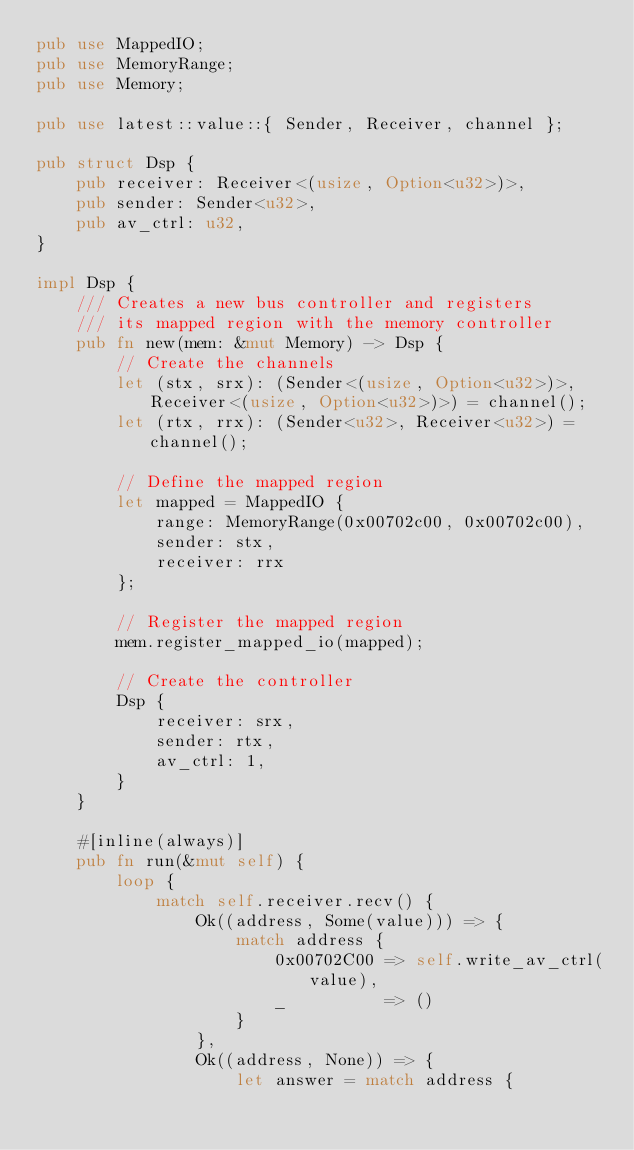Convert code to text. <code><loc_0><loc_0><loc_500><loc_500><_Rust_>pub use MappedIO;
pub use MemoryRange;
pub use Memory;

pub use latest::value::{ Sender, Receiver, channel };

pub struct Dsp {
    pub receiver: Receiver<(usize, Option<u32>)>,
    pub sender: Sender<u32>,
    pub av_ctrl: u32,
}

impl Dsp {
    /// Creates a new bus controller and registers
    /// its mapped region with the memory controller
    pub fn new(mem: &mut Memory) -> Dsp {
        // Create the channels
        let (stx, srx): (Sender<(usize, Option<u32>)>, Receiver<(usize, Option<u32>)>) = channel();
        let (rtx, rrx): (Sender<u32>, Receiver<u32>) = channel();

        // Define the mapped region
        let mapped = MappedIO {
            range: MemoryRange(0x00702c00, 0x00702c00),
            sender: stx,
            receiver: rrx
        };

        // Register the mapped region
        mem.register_mapped_io(mapped);

        // Create the controller
        Dsp {
            receiver: srx,
            sender: rtx,
            av_ctrl: 1,
        }
    }

    #[inline(always)]
    pub fn run(&mut self) {
        loop {
            match self.receiver.recv() {
                Ok((address, Some(value))) => {
                    match address {
                        0x00702C00 => self.write_av_ctrl(value),
                        _          => ()
                    }
                },
                Ok((address, None)) => {
                    let answer = match address {</code> 